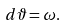Convert formula to latex. <formula><loc_0><loc_0><loc_500><loc_500>d \vartheta = \omega .</formula> 